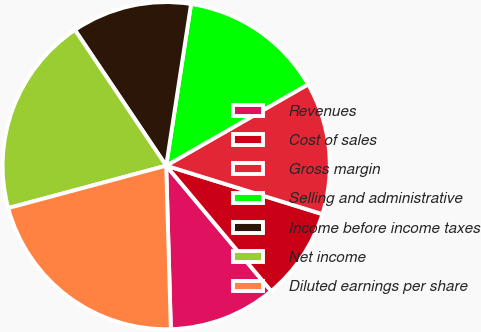Convert chart to OTSL. <chart><loc_0><loc_0><loc_500><loc_500><pie_chart><fcel>Revenues<fcel>Cost of sales<fcel>Gross margin<fcel>Selling and administrative<fcel>Income before income taxes<fcel>Net income<fcel>Diluted earnings per share<nl><fcel>10.64%<fcel>9.12%<fcel>13.07%<fcel>14.29%<fcel>11.85%<fcel>19.76%<fcel>21.28%<nl></chart> 